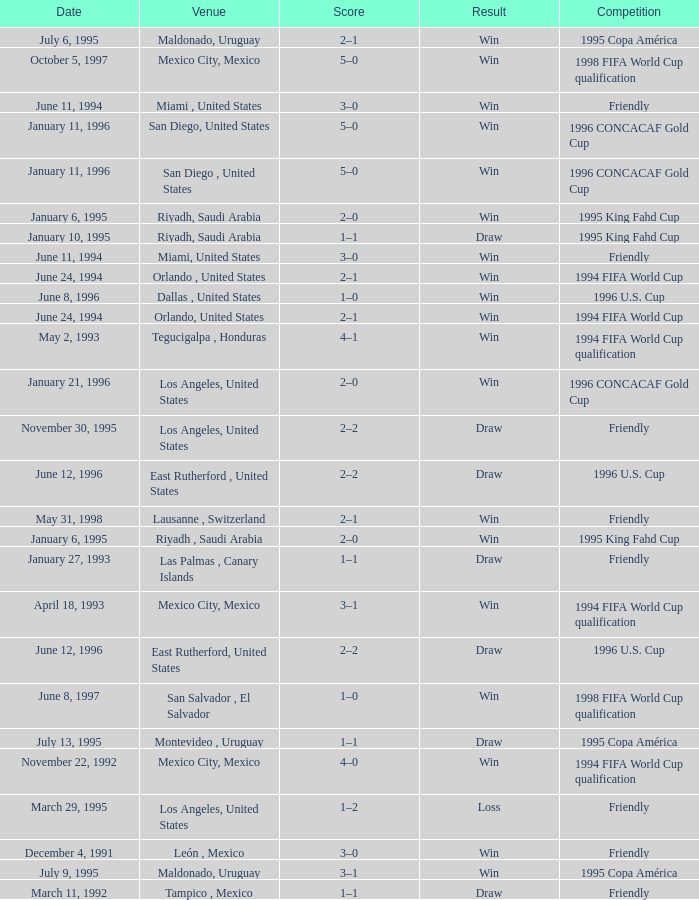What is Result, when Date is "June 11, 1994", and when Venue is "Miami, United States"? Win, Win. 